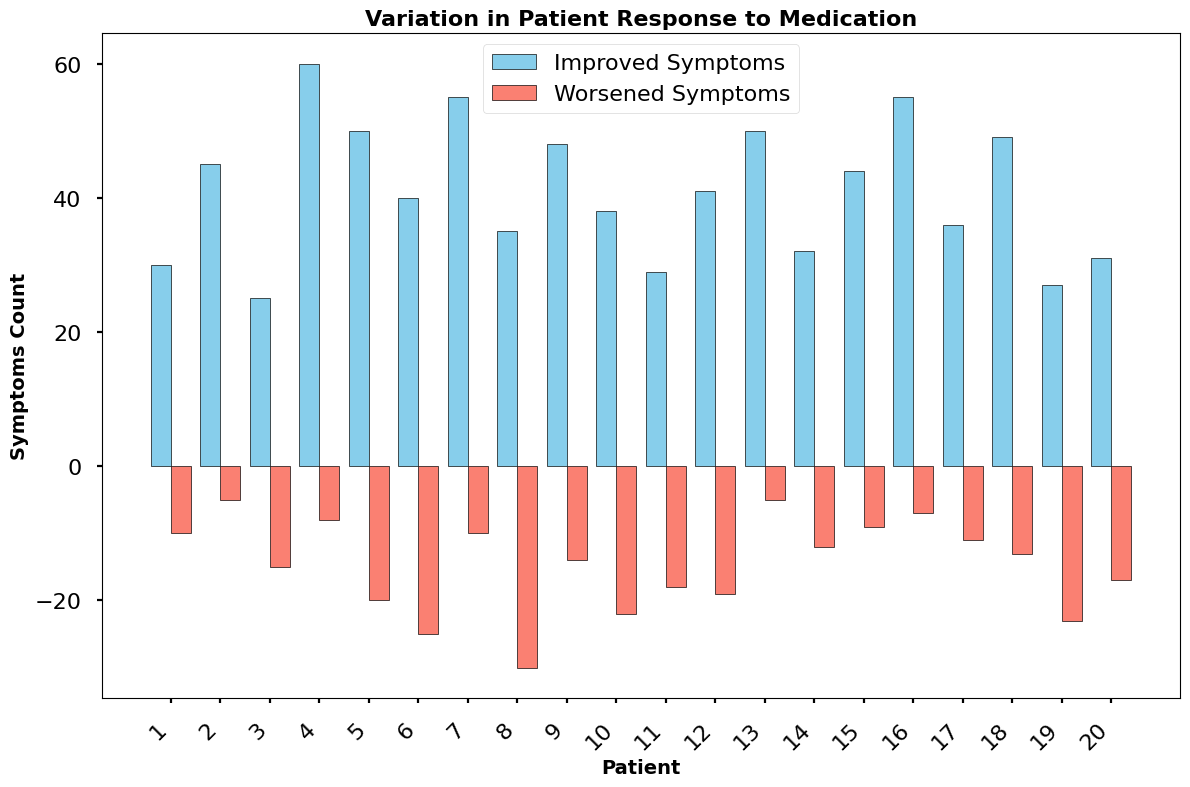What is the total number of improved symptoms across all patients? Sum the values of the "Improved Symptoms" column: 30 + 45 + 25 + 60 + 50 + 40 + 55 + 35 + 48 + 38 + 29 + 41 + 50 + 32 + 44 + 55 + 36 + 49 + 27 + 31. The total is 820.
Answer: 820 Which patient has the highest number of improved symptoms? Look for the bar with the maximum height in the "Improved Symptoms" group. Patient 4 has the highest bar representing 60 improved symptoms.
Answer: Patient 4 What is the difference in worsened symptoms between patient 8 and patient 2? Referring to the "Worsened Symptoms" bars, patient 8 has -30 worsened symptoms and patient 2 has -5 worsened symptoms. The difference is -30 - (-5) = -25.
Answer: -25 Is the number of improved symptoms for patient 7 greater than that for patient 6? Compare the height of the "Improved Symptoms" bars for patient 7 (55) and patient 6 (40). Yes, 55 is greater than 40.
Answer: Yes Which patient has the lowest number of worsened symptoms? Look for the shortest bar in the "Worsened Symptoms" group. Patient 2 has the shortest bar representing -5 worsened symptoms.
Answer: Patient 2 What is the average number of improved symptoms per patient? Divide the total number of improved symptoms (820) by the total number of patients (20). The average is 820/20 = 41.
Answer: 41 Among patients 10, 11, and 12, who has the least worsened symptoms? Compare the "Worsened Symptoms" bars for patients 10 (-22), 11 (-18), and 12 (-19). Patient 11 has the least worsened symptoms.
Answer: Patient 11 Does any patient have exactly 50 improved symptoms? Check the "Improved Symptoms" bars to see if any of them reaches to 50. Both patient 5 and patient 13 have exactly 50 improved symptoms.
Answer: Patient 5 and Patient 13 What is the combined number of worsened symptoms for patients 1 and 20? Sum the values of the "Worsened Symptoms" column for patients 1 (-10) and 20 (-17). The combined number is -10 + (-17) = -27.
Answer: -27 Is the bar for worsened symptoms for patient 6 shorter than the bar for improved symptoms for patient 6? Compare the height of the bars for patient 6 in both groups. The "Worsened Symptoms" bar (-25) is shorter (negative value) than the "Improved Symptoms" bar (40).
Answer: Yes 